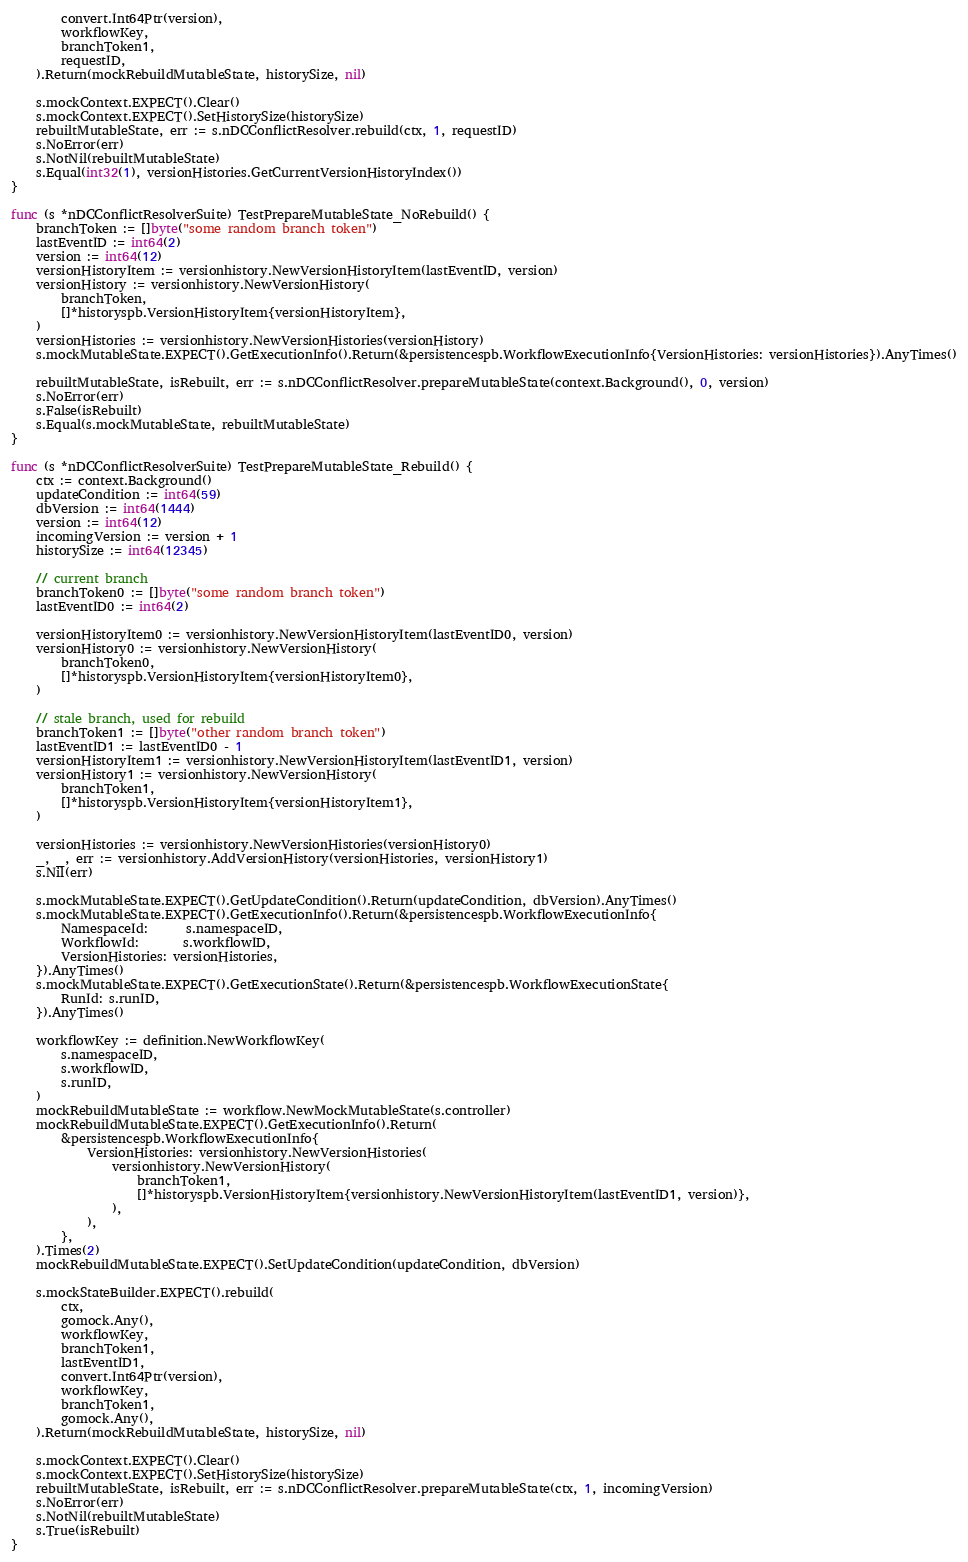<code> <loc_0><loc_0><loc_500><loc_500><_Go_>		convert.Int64Ptr(version),
		workflowKey,
		branchToken1,
		requestID,
	).Return(mockRebuildMutableState, historySize, nil)

	s.mockContext.EXPECT().Clear()
	s.mockContext.EXPECT().SetHistorySize(historySize)
	rebuiltMutableState, err := s.nDCConflictResolver.rebuild(ctx, 1, requestID)
	s.NoError(err)
	s.NotNil(rebuiltMutableState)
	s.Equal(int32(1), versionHistories.GetCurrentVersionHistoryIndex())
}

func (s *nDCConflictResolverSuite) TestPrepareMutableState_NoRebuild() {
	branchToken := []byte("some random branch token")
	lastEventID := int64(2)
	version := int64(12)
	versionHistoryItem := versionhistory.NewVersionHistoryItem(lastEventID, version)
	versionHistory := versionhistory.NewVersionHistory(
		branchToken,
		[]*historyspb.VersionHistoryItem{versionHistoryItem},
	)
	versionHistories := versionhistory.NewVersionHistories(versionHistory)
	s.mockMutableState.EXPECT().GetExecutionInfo().Return(&persistencespb.WorkflowExecutionInfo{VersionHistories: versionHistories}).AnyTimes()

	rebuiltMutableState, isRebuilt, err := s.nDCConflictResolver.prepareMutableState(context.Background(), 0, version)
	s.NoError(err)
	s.False(isRebuilt)
	s.Equal(s.mockMutableState, rebuiltMutableState)
}

func (s *nDCConflictResolverSuite) TestPrepareMutableState_Rebuild() {
	ctx := context.Background()
	updateCondition := int64(59)
	dbVersion := int64(1444)
	version := int64(12)
	incomingVersion := version + 1
	historySize := int64(12345)

	// current branch
	branchToken0 := []byte("some random branch token")
	lastEventID0 := int64(2)

	versionHistoryItem0 := versionhistory.NewVersionHistoryItem(lastEventID0, version)
	versionHistory0 := versionhistory.NewVersionHistory(
		branchToken0,
		[]*historyspb.VersionHistoryItem{versionHistoryItem0},
	)

	// stale branch, used for rebuild
	branchToken1 := []byte("other random branch token")
	lastEventID1 := lastEventID0 - 1
	versionHistoryItem1 := versionhistory.NewVersionHistoryItem(lastEventID1, version)
	versionHistory1 := versionhistory.NewVersionHistory(
		branchToken1,
		[]*historyspb.VersionHistoryItem{versionHistoryItem1},
	)

	versionHistories := versionhistory.NewVersionHistories(versionHistory0)
	_, _, err := versionhistory.AddVersionHistory(versionHistories, versionHistory1)
	s.Nil(err)

	s.mockMutableState.EXPECT().GetUpdateCondition().Return(updateCondition, dbVersion).AnyTimes()
	s.mockMutableState.EXPECT().GetExecutionInfo().Return(&persistencespb.WorkflowExecutionInfo{
		NamespaceId:      s.namespaceID,
		WorkflowId:       s.workflowID,
		VersionHistories: versionHistories,
	}).AnyTimes()
	s.mockMutableState.EXPECT().GetExecutionState().Return(&persistencespb.WorkflowExecutionState{
		RunId: s.runID,
	}).AnyTimes()

	workflowKey := definition.NewWorkflowKey(
		s.namespaceID,
		s.workflowID,
		s.runID,
	)
	mockRebuildMutableState := workflow.NewMockMutableState(s.controller)
	mockRebuildMutableState.EXPECT().GetExecutionInfo().Return(
		&persistencespb.WorkflowExecutionInfo{
			VersionHistories: versionhistory.NewVersionHistories(
				versionhistory.NewVersionHistory(
					branchToken1,
					[]*historyspb.VersionHistoryItem{versionhistory.NewVersionHistoryItem(lastEventID1, version)},
				),
			),
		},
	).Times(2)
	mockRebuildMutableState.EXPECT().SetUpdateCondition(updateCondition, dbVersion)

	s.mockStateBuilder.EXPECT().rebuild(
		ctx,
		gomock.Any(),
		workflowKey,
		branchToken1,
		lastEventID1,
		convert.Int64Ptr(version),
		workflowKey,
		branchToken1,
		gomock.Any(),
	).Return(mockRebuildMutableState, historySize, nil)

	s.mockContext.EXPECT().Clear()
	s.mockContext.EXPECT().SetHistorySize(historySize)
	rebuiltMutableState, isRebuilt, err := s.nDCConflictResolver.prepareMutableState(ctx, 1, incomingVersion)
	s.NoError(err)
	s.NotNil(rebuiltMutableState)
	s.True(isRebuilt)
}
</code> 